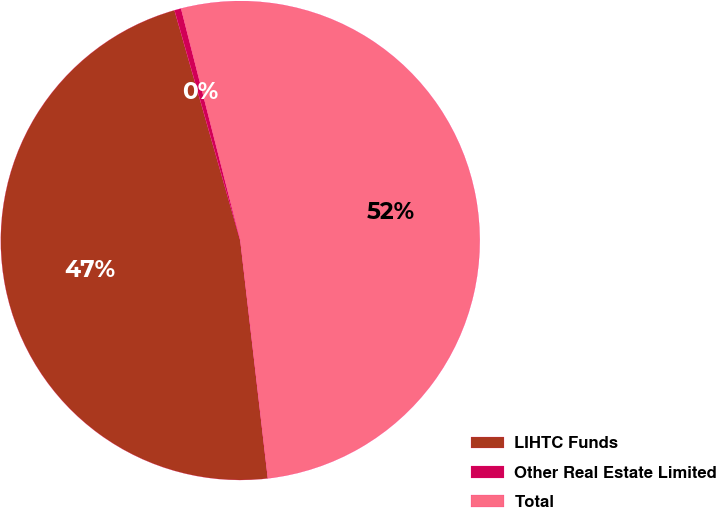Convert chart. <chart><loc_0><loc_0><loc_500><loc_500><pie_chart><fcel>LIHTC Funds<fcel>Other Real Estate Limited<fcel>Total<nl><fcel>47.4%<fcel>0.45%<fcel>52.14%<nl></chart> 